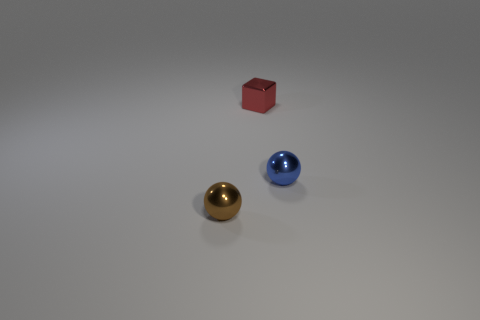Is the number of blue spheres that are in front of the small brown metallic sphere the same as the number of balls to the right of the blue sphere?
Keep it short and to the point. Yes. What is the blue thing made of?
Make the answer very short. Metal. There is a metallic sphere that is the same size as the blue object; what color is it?
Your response must be concise. Brown. There is a red block to the right of the brown object; are there any small red cubes behind it?
Keep it short and to the point. No. How many spheres are either red shiny objects or brown shiny objects?
Give a very brief answer. 1. There is a sphere that is behind the sphere that is in front of the tiny thing that is to the right of the tiny red thing; what is its size?
Your response must be concise. Small. Are there any tiny red cubes in front of the small red shiny thing?
Provide a succinct answer. No. What number of objects are small shiny spheres in front of the tiny blue object or big purple matte cylinders?
Your answer should be very brief. 1. The brown object that is the same material as the small cube is what size?
Ensure brevity in your answer.  Small. Do the cube and the metallic thing to the right of the red metal cube have the same size?
Keep it short and to the point. Yes. 